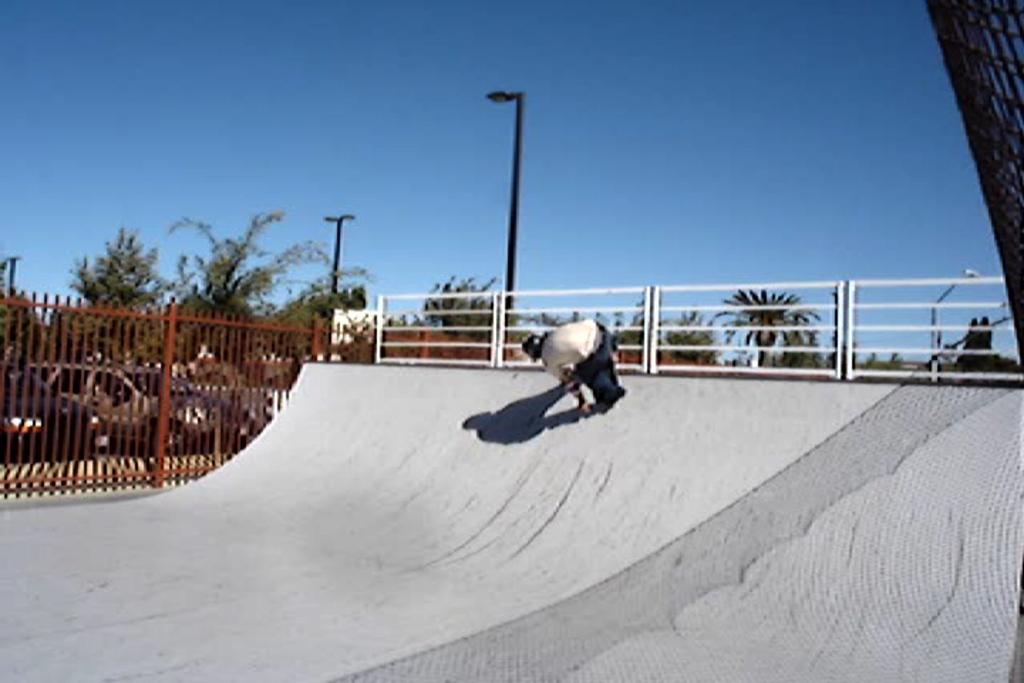What is the person in the image doing? The person is visible on the skating surface, so they are likely skating. What is located beside the skating surface? There is a fence beside the skating surface. What other objects can be seen in the image? There are poles and vehicles present? What type of natural elements are visible in the image? There are trees in the image. What is visible at the top of the image? The sky is visible at the top of the image. How does the person tie a knot with the wool while skating in the image? There is no wool or knot-tying activity present in the image; the person is simply skating. 